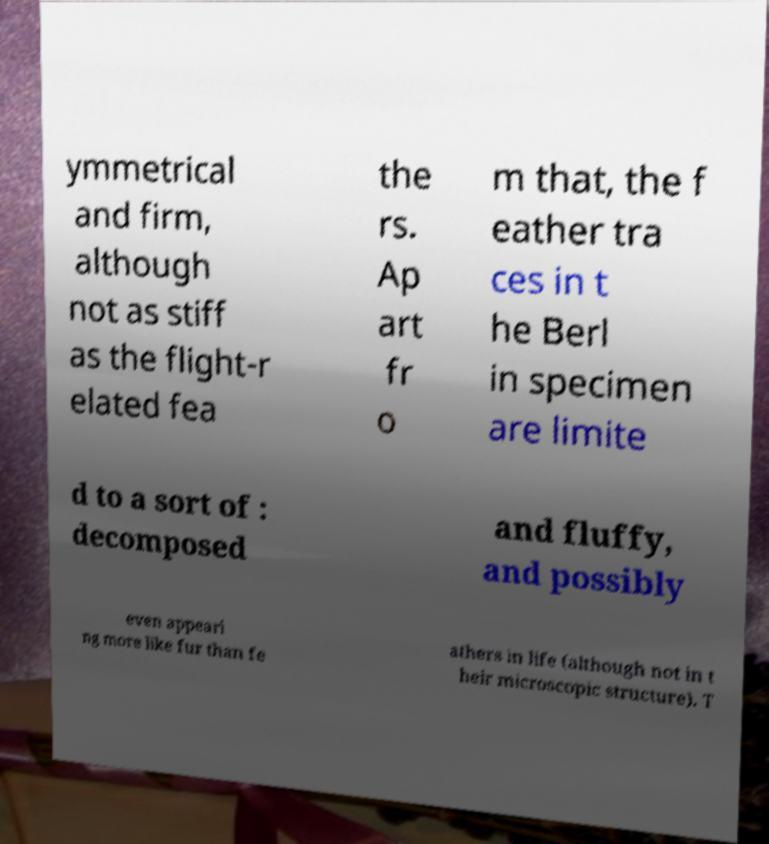Could you extract and type out the text from this image? ymmetrical and firm, although not as stiff as the flight-r elated fea the rs. Ap art fr o m that, the f eather tra ces in t he Berl in specimen are limite d to a sort of : decomposed and fluffy, and possibly even appeari ng more like fur than fe athers in life (although not in t heir microscopic structure). T 